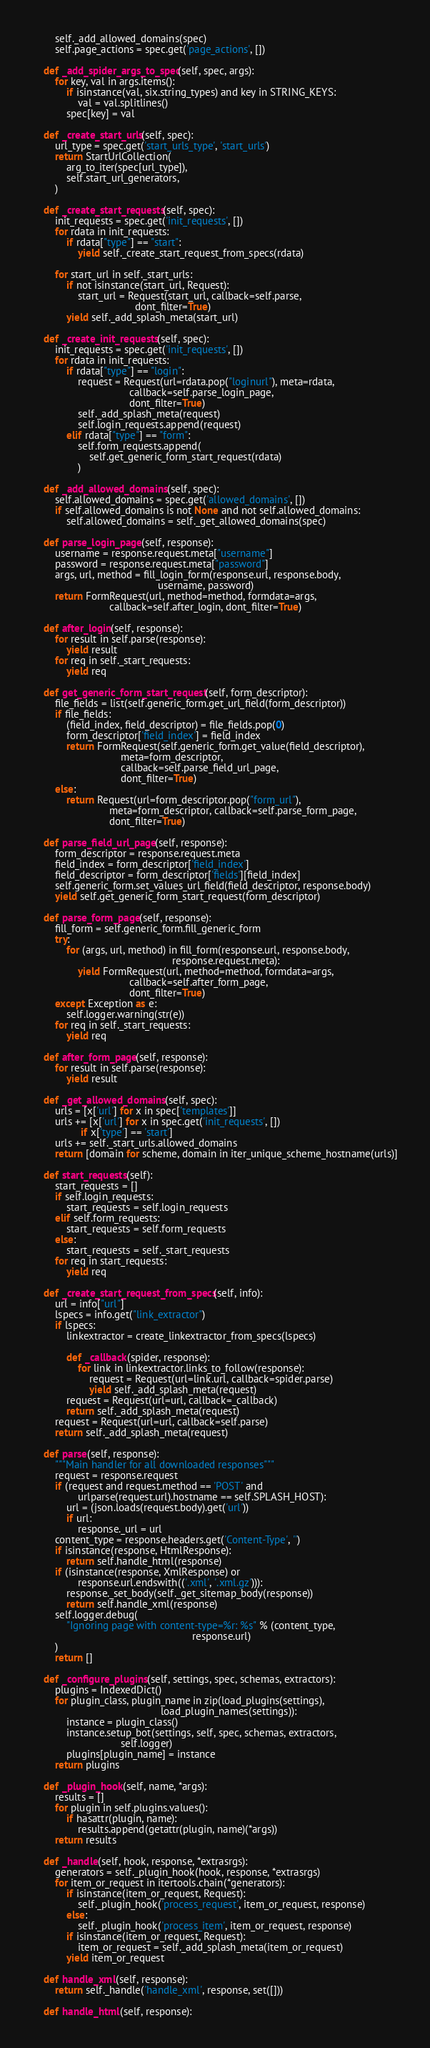<code> <loc_0><loc_0><loc_500><loc_500><_Python_>        self._add_allowed_domains(spec)
        self.page_actions = spec.get('page_actions', [])

    def _add_spider_args_to_spec(self, spec, args):
        for key, val in args.items():
            if isinstance(val, six.string_types) and key in STRING_KEYS:
                val = val.splitlines()
            spec[key] = val

    def _create_start_urls(self, spec):
        url_type = spec.get('start_urls_type', 'start_urls')
        return StartUrlCollection(
            arg_to_iter(spec[url_type]),
            self.start_url_generators,
        )

    def _create_start_requests(self, spec):
        init_requests = spec.get('init_requests', [])
        for rdata in init_requests:
            if rdata["type"] == "start":
                yield self._create_start_request_from_specs(rdata)

        for start_url in self._start_urls:
            if not isinstance(start_url, Request):
                start_url = Request(start_url, callback=self.parse,
                                    dont_filter=True)
            yield self._add_splash_meta(start_url)

    def _create_init_requests(self, spec):
        init_requests = spec.get('init_requests', [])
        for rdata in init_requests:
            if rdata["type"] == "login":
                request = Request(url=rdata.pop("loginurl"), meta=rdata,
                                  callback=self.parse_login_page,
                                  dont_filter=True)
                self._add_splash_meta(request)
                self.login_requests.append(request)
            elif rdata["type"] == "form":
                self.form_requests.append(
                    self.get_generic_form_start_request(rdata)
                )

    def _add_allowed_domains(self, spec):
        self.allowed_domains = spec.get('allowed_domains', [])
        if self.allowed_domains is not None and not self.allowed_domains:
            self.allowed_domains = self._get_allowed_domains(spec)

    def parse_login_page(self, response):
        username = response.request.meta["username"]
        password = response.request.meta["password"]
        args, url, method = fill_login_form(response.url, response.body,
                                            username, password)
        return FormRequest(url, method=method, formdata=args,
                           callback=self.after_login, dont_filter=True)

    def after_login(self, response):
        for result in self.parse(response):
            yield result
        for req in self._start_requests:
            yield req

    def get_generic_form_start_request(self, form_descriptor):
        file_fields = list(self.generic_form.get_url_field(form_descriptor))
        if file_fields:
            (field_index, field_descriptor) = file_fields.pop(0)
            form_descriptor['field_index'] = field_index
            return FormRequest(self.generic_form.get_value(field_descriptor),
                               meta=form_descriptor,
                               callback=self.parse_field_url_page,
                               dont_filter=True)
        else:
            return Request(url=form_descriptor.pop("form_url"),
                           meta=form_descriptor, callback=self.parse_form_page,
                           dont_filter=True)

    def parse_field_url_page(self, response):
        form_descriptor = response.request.meta
        field_index = form_descriptor['field_index']
        field_descriptor = form_descriptor['fields'][field_index]
        self.generic_form.set_values_url_field(field_descriptor, response.body)
        yield self.get_generic_form_start_request(form_descriptor)

    def parse_form_page(self, response):
        fill_form = self.generic_form.fill_generic_form
        try:
            for (args, url, method) in fill_form(response.url, response.body,
                                                 response.request.meta):
                yield FormRequest(url, method=method, formdata=args,
                                  callback=self.after_form_page,
                                  dont_filter=True)
        except Exception as e:
            self.logger.warning(str(e))
        for req in self._start_requests:
            yield req

    def after_form_page(self, response):
        for result in self.parse(response):
            yield result

    def _get_allowed_domains(self, spec):
        urls = [x['url'] for x in spec['templates']]
        urls += [x['url'] for x in spec.get('init_requests', [])
                 if x['type'] == 'start']
        urls += self._start_urls.allowed_domains
        return [domain for scheme, domain in iter_unique_scheme_hostname(urls)]

    def start_requests(self):
        start_requests = []
        if self.login_requests:
            start_requests = self.login_requests
        elif self.form_requests:
            start_requests = self.form_requests
        else:
            start_requests = self._start_requests
        for req in start_requests:
            yield req

    def _create_start_request_from_specs(self, info):
        url = info["url"]
        lspecs = info.get("link_extractor")
        if lspecs:
            linkextractor = create_linkextractor_from_specs(lspecs)

            def _callback(spider, response):
                for link in linkextractor.links_to_follow(response):
                    request = Request(url=link.url, callback=spider.parse)
                    yield self._add_splash_meta(request)
            request = Request(url=url, callback=_callback)
            return self._add_splash_meta(request)
        request = Request(url=url, callback=self.parse)
        return self._add_splash_meta(request)

    def parse(self, response):
        """Main handler for all downloaded responses"""
        request = response.request
        if (request and request.method == 'POST' and
                urlparse(request.url).hostname == self.SPLASH_HOST):
            url = (json.loads(request.body).get('url'))
            if url:
                response._url = url
        content_type = response.headers.get('Content-Type', '')
        if isinstance(response, HtmlResponse):
            return self.handle_html(response)
        if (isinstance(response, XmlResponse) or
                response.url.endswith(('.xml', '.xml.gz'))):
            response._set_body(self._get_sitemap_body(response))
            return self.handle_xml(response)
        self.logger.debug(
            "Ignoring page with content-type=%r: %s" % (content_type,
                                                        response.url)
        )
        return []

    def _configure_plugins(self, settings, spec, schemas, extractors):
        plugins = IndexedDict()
        for plugin_class, plugin_name in zip(load_plugins(settings),
                                             load_plugin_names(settings)):
            instance = plugin_class()
            instance.setup_bot(settings, self, spec, schemas, extractors,
                               self.logger)
            plugins[plugin_name] = instance
        return plugins

    def _plugin_hook(self, name, *args):
        results = []
        for plugin in self.plugins.values():
            if hasattr(plugin, name):
                results.append(getattr(plugin, name)(*args))
        return results

    def _handle(self, hook, response, *extrasrgs):
        generators = self._plugin_hook(hook, response, *extrasrgs)
        for item_or_request in itertools.chain(*generators):
            if isinstance(item_or_request, Request):
                self._plugin_hook('process_request', item_or_request, response)
            else:
                self._plugin_hook('process_item', item_or_request, response)
            if isinstance(item_or_request, Request):
                item_or_request = self._add_splash_meta(item_or_request)
            yield item_or_request

    def handle_xml(self, response):
        return self._handle('handle_xml', response, set([]))

    def handle_html(self, response):</code> 